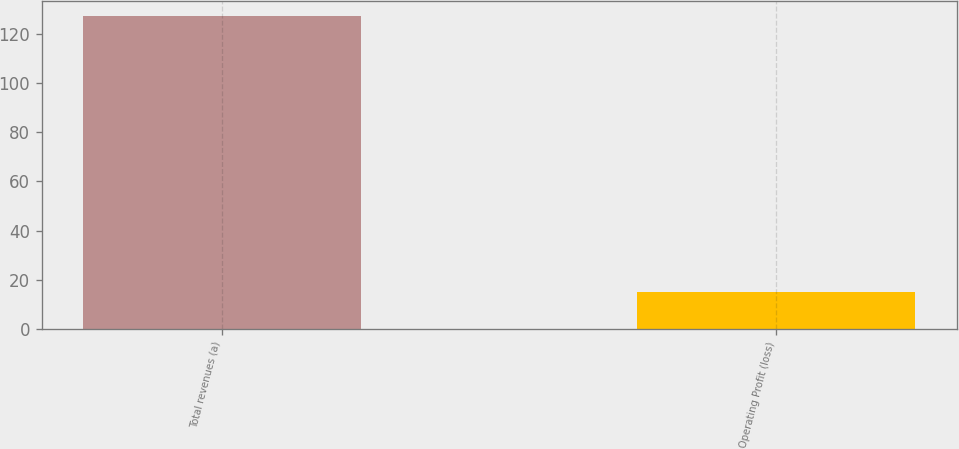Convert chart. <chart><loc_0><loc_0><loc_500><loc_500><bar_chart><fcel>Total revenues (a)<fcel>Operating Profit (loss)<nl><fcel>127<fcel>15<nl></chart> 